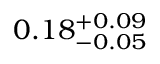Convert formula to latex. <formula><loc_0><loc_0><loc_500><loc_500>0 . 1 8 _ { - 0 . 0 5 } ^ { + 0 . 0 9 }</formula> 